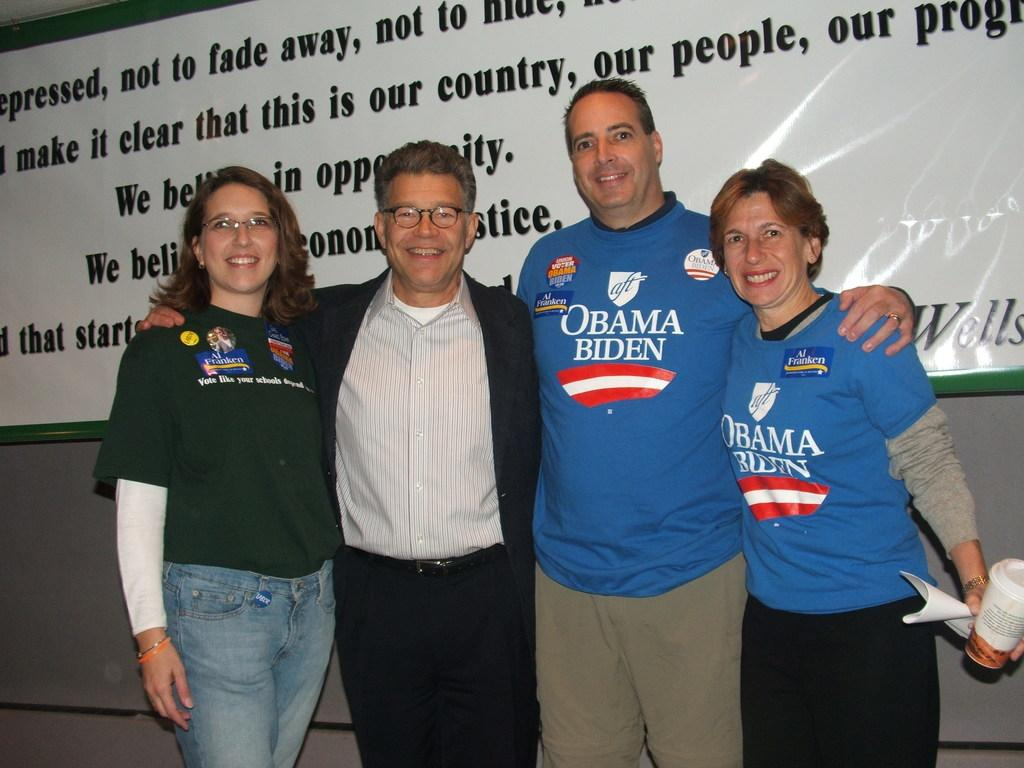<image>
Provide a brief description of the given image. An Al Franken supporter and two Obama-Biden supporters pose for a picture with the candidate, Al Franken. 